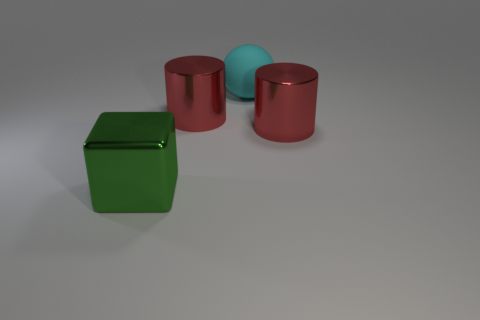How many objects are red things or big green metal cubes?
Offer a terse response. 3. What is the size of the shiny thing behind the red metal cylinder that is to the right of the large ball?
Provide a short and direct response. Large. What is the size of the ball?
Provide a succinct answer. Large. There is a large object that is both to the right of the big shiny cube and left of the big cyan object; what shape is it?
Your answer should be very brief. Cylinder. How many things are either things right of the cyan ball or things that are behind the big green block?
Offer a terse response. 3. What shape is the large cyan rubber thing?
Make the answer very short. Sphere. How many large green cubes are made of the same material as the ball?
Make the answer very short. 0. The metallic block has what color?
Provide a succinct answer. Green. What color is the block that is the same size as the cyan object?
Offer a terse response. Green. Is there a small matte ball that has the same color as the big matte thing?
Your response must be concise. No. 